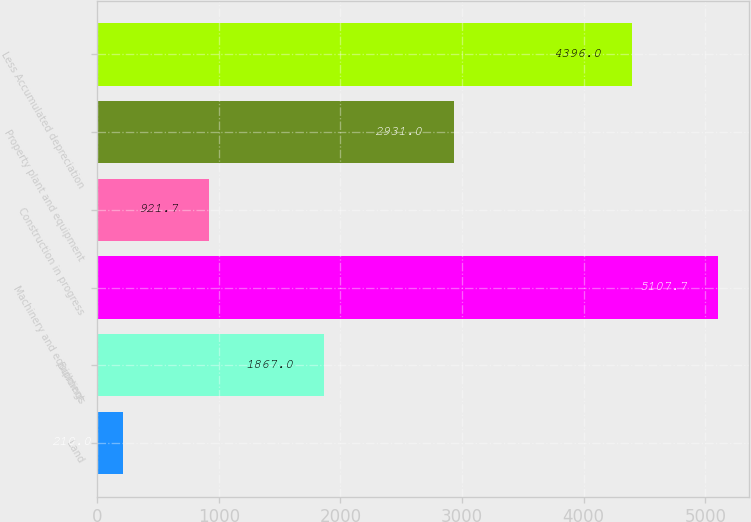<chart> <loc_0><loc_0><loc_500><loc_500><bar_chart><fcel>Land<fcel>Buildings<fcel>Machinery and equipment<fcel>Construction in progress<fcel>Property plant and equipment<fcel>Less Accumulated depreciation<nl><fcel>210<fcel>1867<fcel>5107.7<fcel>921.7<fcel>2931<fcel>4396<nl></chart> 